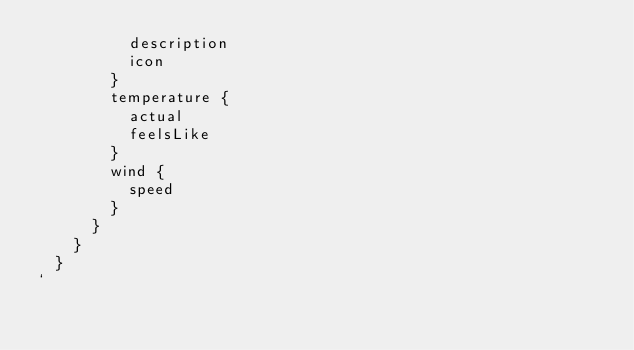Convert code to text. <code><loc_0><loc_0><loc_500><loc_500><_JavaScript_>          description
          icon
        }
        temperature {
          actual
          feelsLike
        }
        wind {
          speed
        }
      }
    }
  }
`</code> 